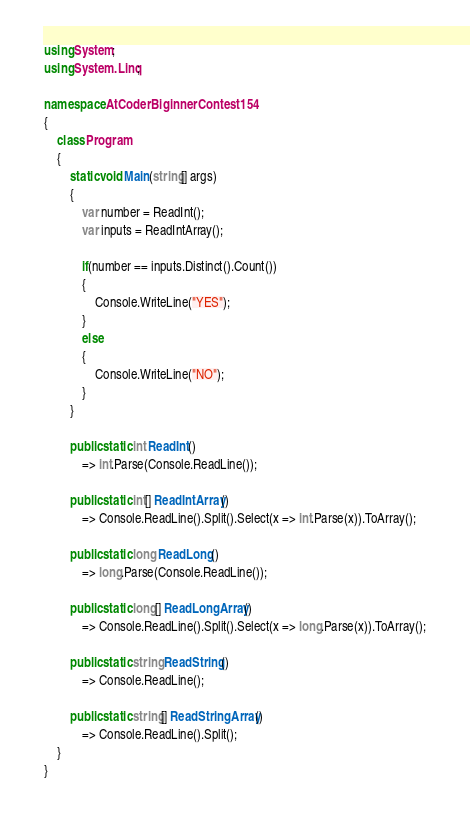Convert code to text. <code><loc_0><loc_0><loc_500><loc_500><_C#_>using System;
using System.Linq;

namespace AtCoderBiginnerContest154
{
	class Program
	{
		static void Main(string[] args)
		{
			var number = ReadInt();
			var inputs = ReadIntArray();

			if(number == inputs.Distinct().Count())
			{
				Console.WriteLine("YES");
			}
			else
			{
				Console.WriteLine("NO");
			}
		}

		public static int ReadInt()
			=> int.Parse(Console.ReadLine());

		public static int[] ReadIntArray()
			=> Console.ReadLine().Split().Select(x => int.Parse(x)).ToArray();

		public static long ReadLong()
			=> long.Parse(Console.ReadLine());

		public static long[] ReadLongArray()
			=> Console.ReadLine().Split().Select(x => long.Parse(x)).ToArray();

		public static string ReadString()
			=> Console.ReadLine();

		public static string[] ReadStringArray()
			=> Console.ReadLine().Split();
	}
}
</code> 